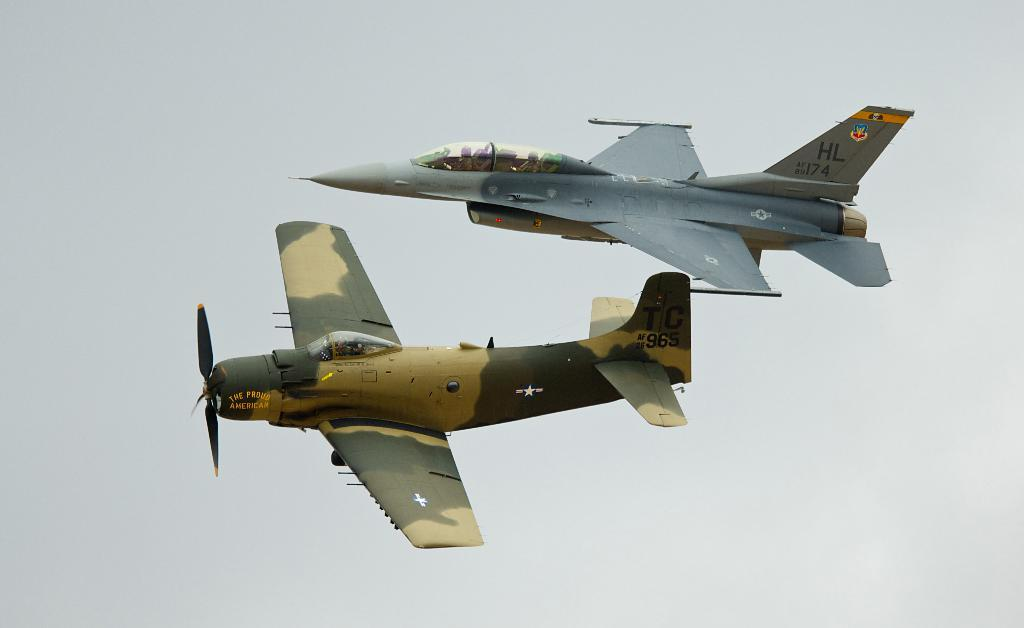<image>
Relay a brief, clear account of the picture shown. Two military aircraft with call letters barely visible fly very close to one another. 